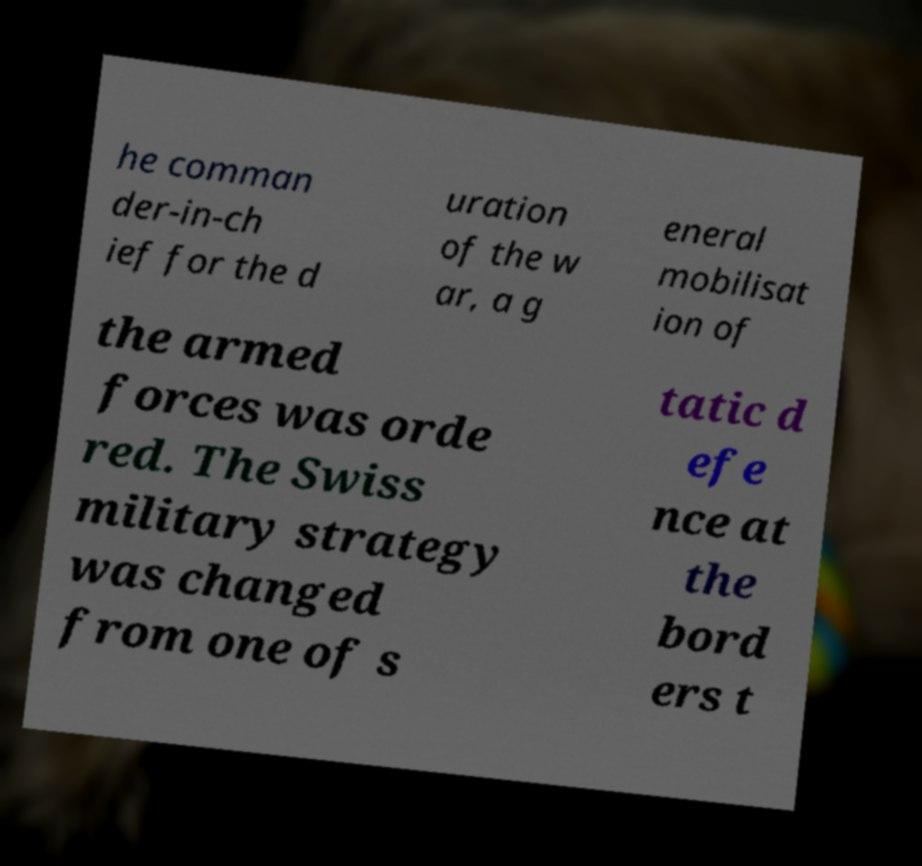Could you assist in decoding the text presented in this image and type it out clearly? he comman der-in-ch ief for the d uration of the w ar, a g eneral mobilisat ion of the armed forces was orde red. The Swiss military strategy was changed from one of s tatic d efe nce at the bord ers t 